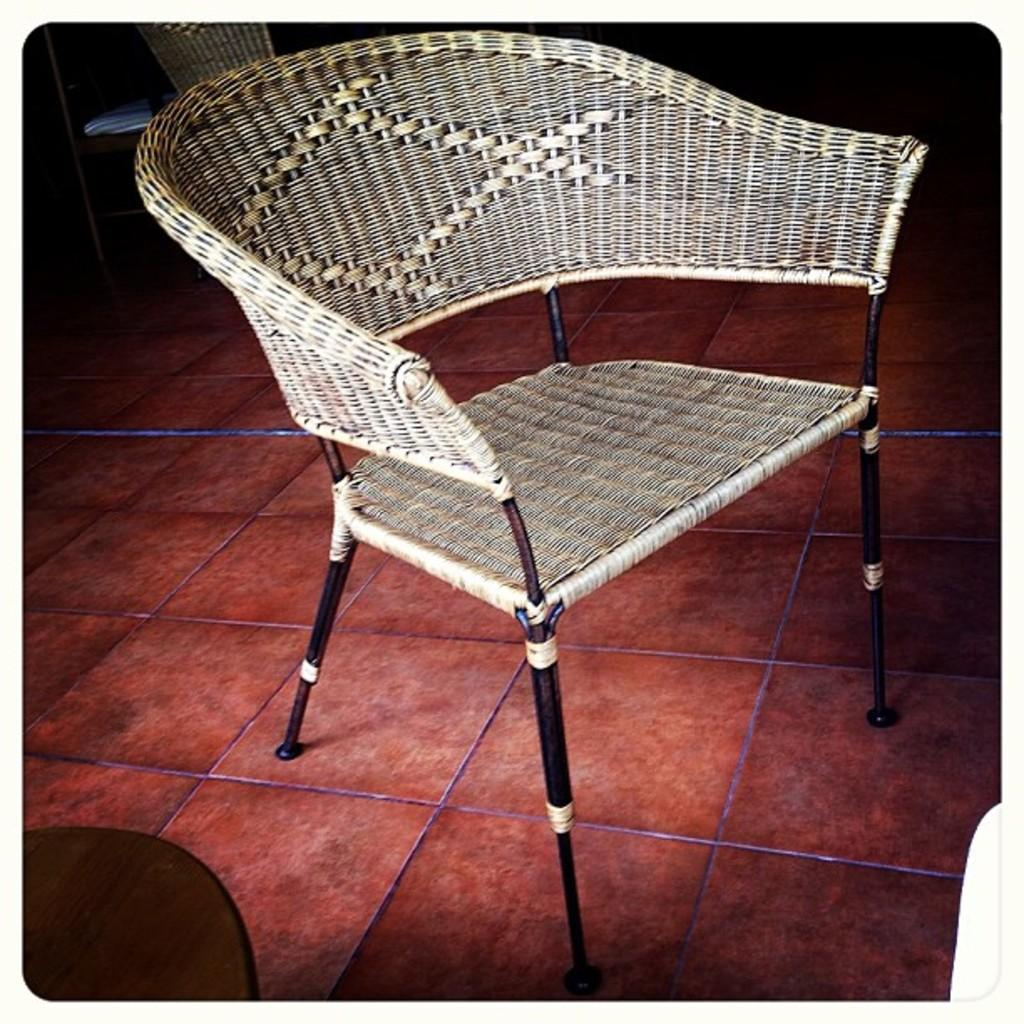What piece of furniture is present in the image? There is a chair in the image. Where is the chair located in the image? The chair is on the floor. How does the beginner use the chair in the image? There is no indication in the image of a beginner using the chair, nor is there any information about how the chair is being used. 